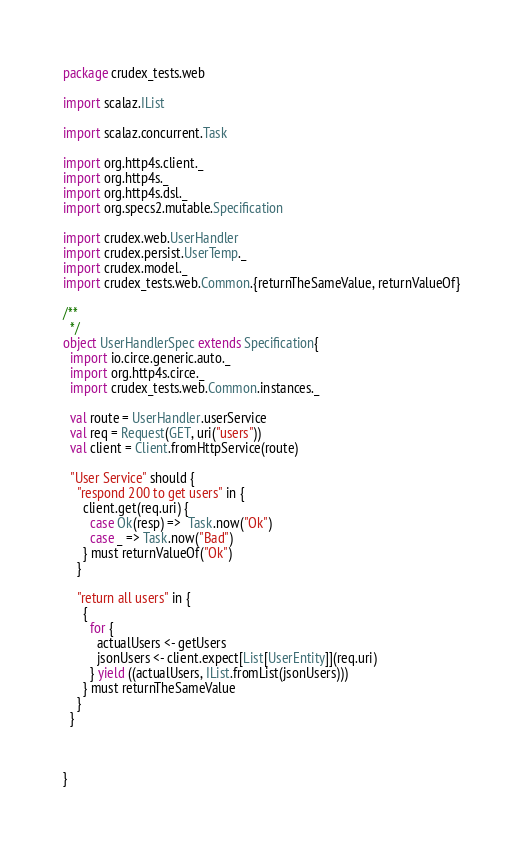Convert code to text. <code><loc_0><loc_0><loc_500><loc_500><_Scala_>package crudex_tests.web

import scalaz.IList

import scalaz.concurrent.Task

import org.http4s.client._
import org.http4s._
import org.http4s.dsl._
import org.specs2.mutable.Specification

import crudex.web.UserHandler
import crudex.persist.UserTemp._
import crudex.model._
import crudex_tests.web.Common.{returnTheSameValue, returnValueOf}

/**
  */
object UserHandlerSpec extends Specification{
  import io.circe.generic.auto._
  import org.http4s.circe._
  import crudex_tests.web.Common.instances._

  val route = UserHandler.userService
  val req = Request(GET, uri("users"))
  val client = Client.fromHttpService(route)

  "User Service" should {
    "respond 200 to get users" in {
      client.get(req.uri) {
        case Ok(resp) =>  Task.now("Ok")
        case _ => Task.now("Bad")
      } must returnValueOf("Ok")
    }

    "return all users" in {
      {
        for {
          actualUsers <- getUsers
          jsonUsers <- client.expect[List[UserEntity]](req.uri)
        } yield ((actualUsers, IList.fromList(jsonUsers)))
      } must returnTheSameValue
    }
  }



}
</code> 